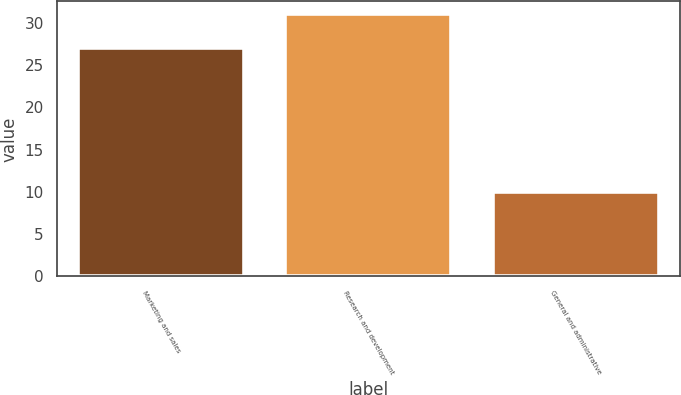<chart> <loc_0><loc_0><loc_500><loc_500><bar_chart><fcel>Marketing and sales<fcel>Research and development<fcel>General and administrative<nl><fcel>27<fcel>31<fcel>10<nl></chart> 